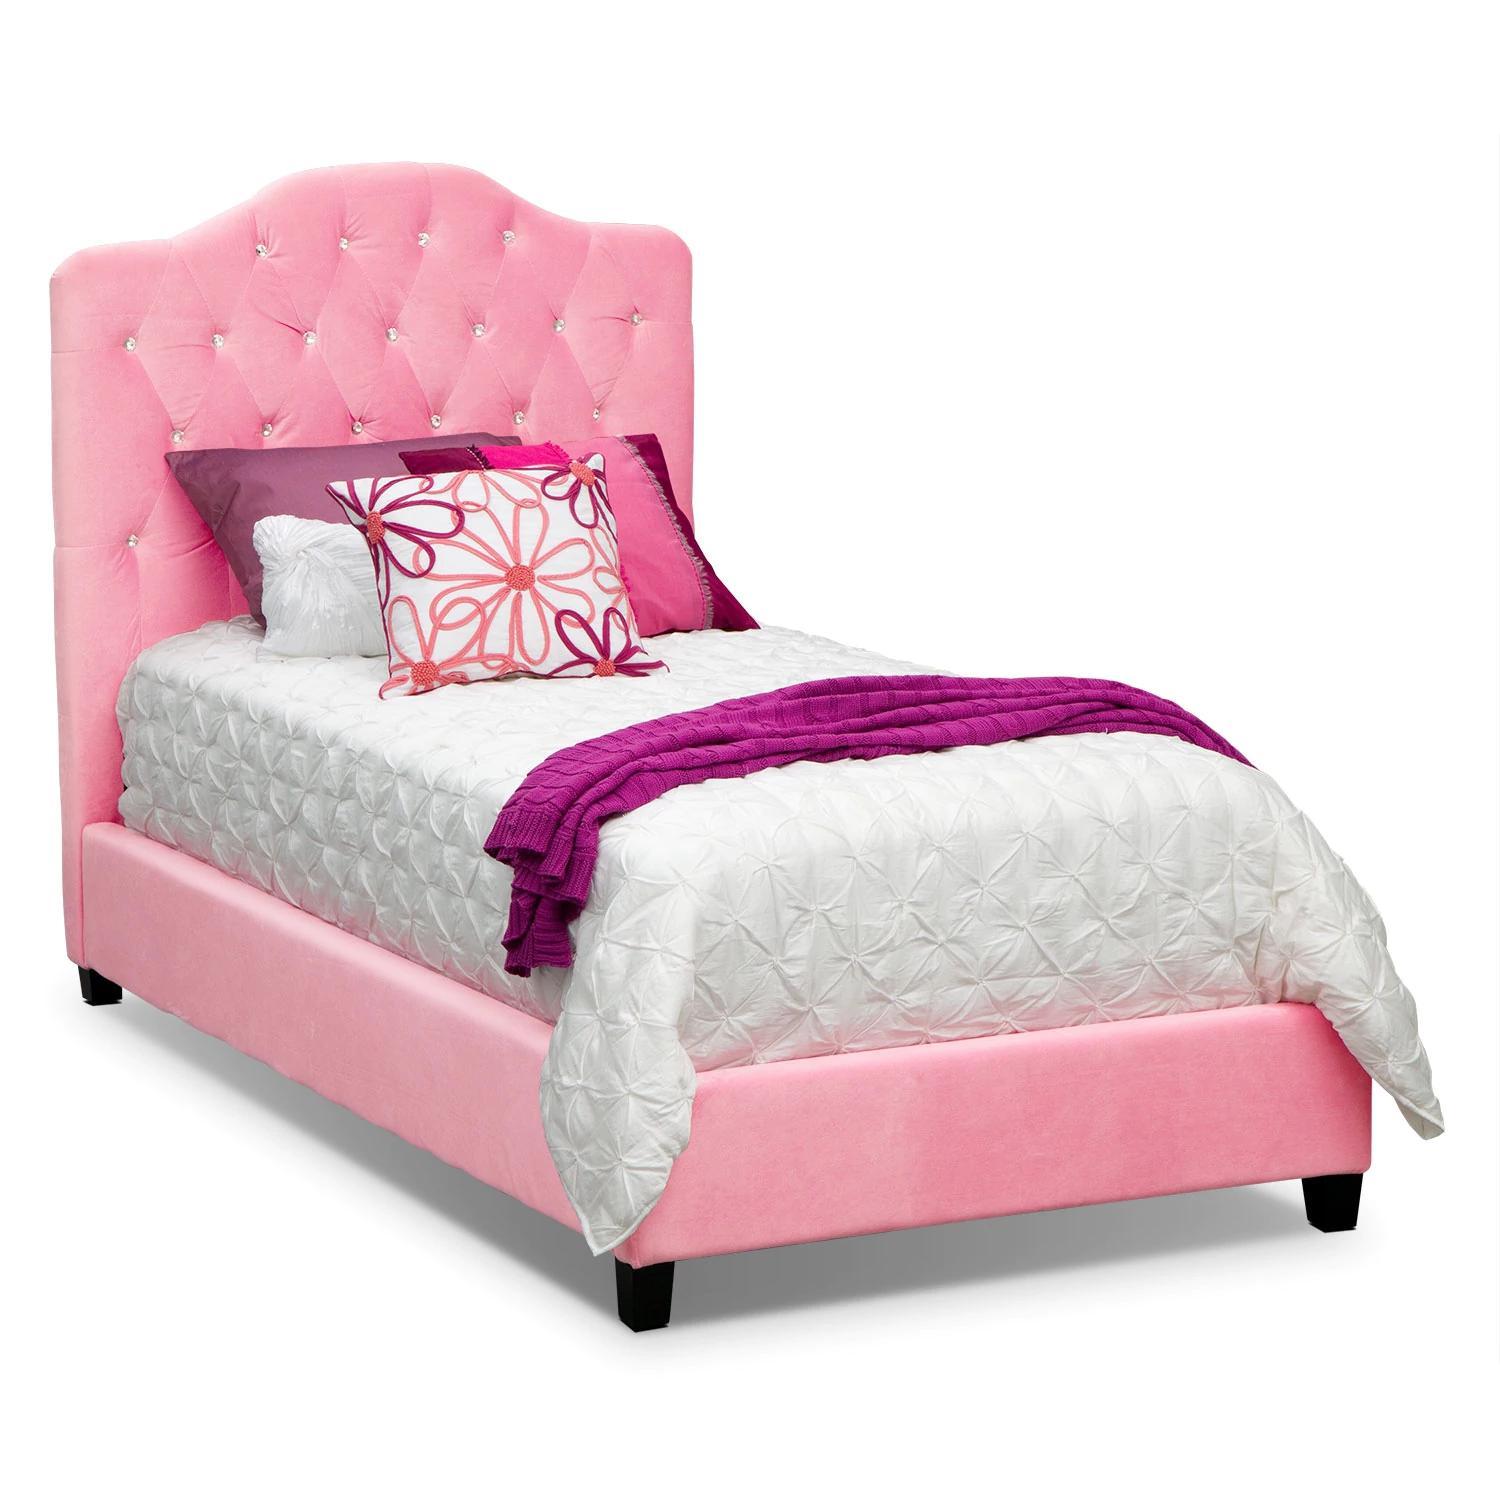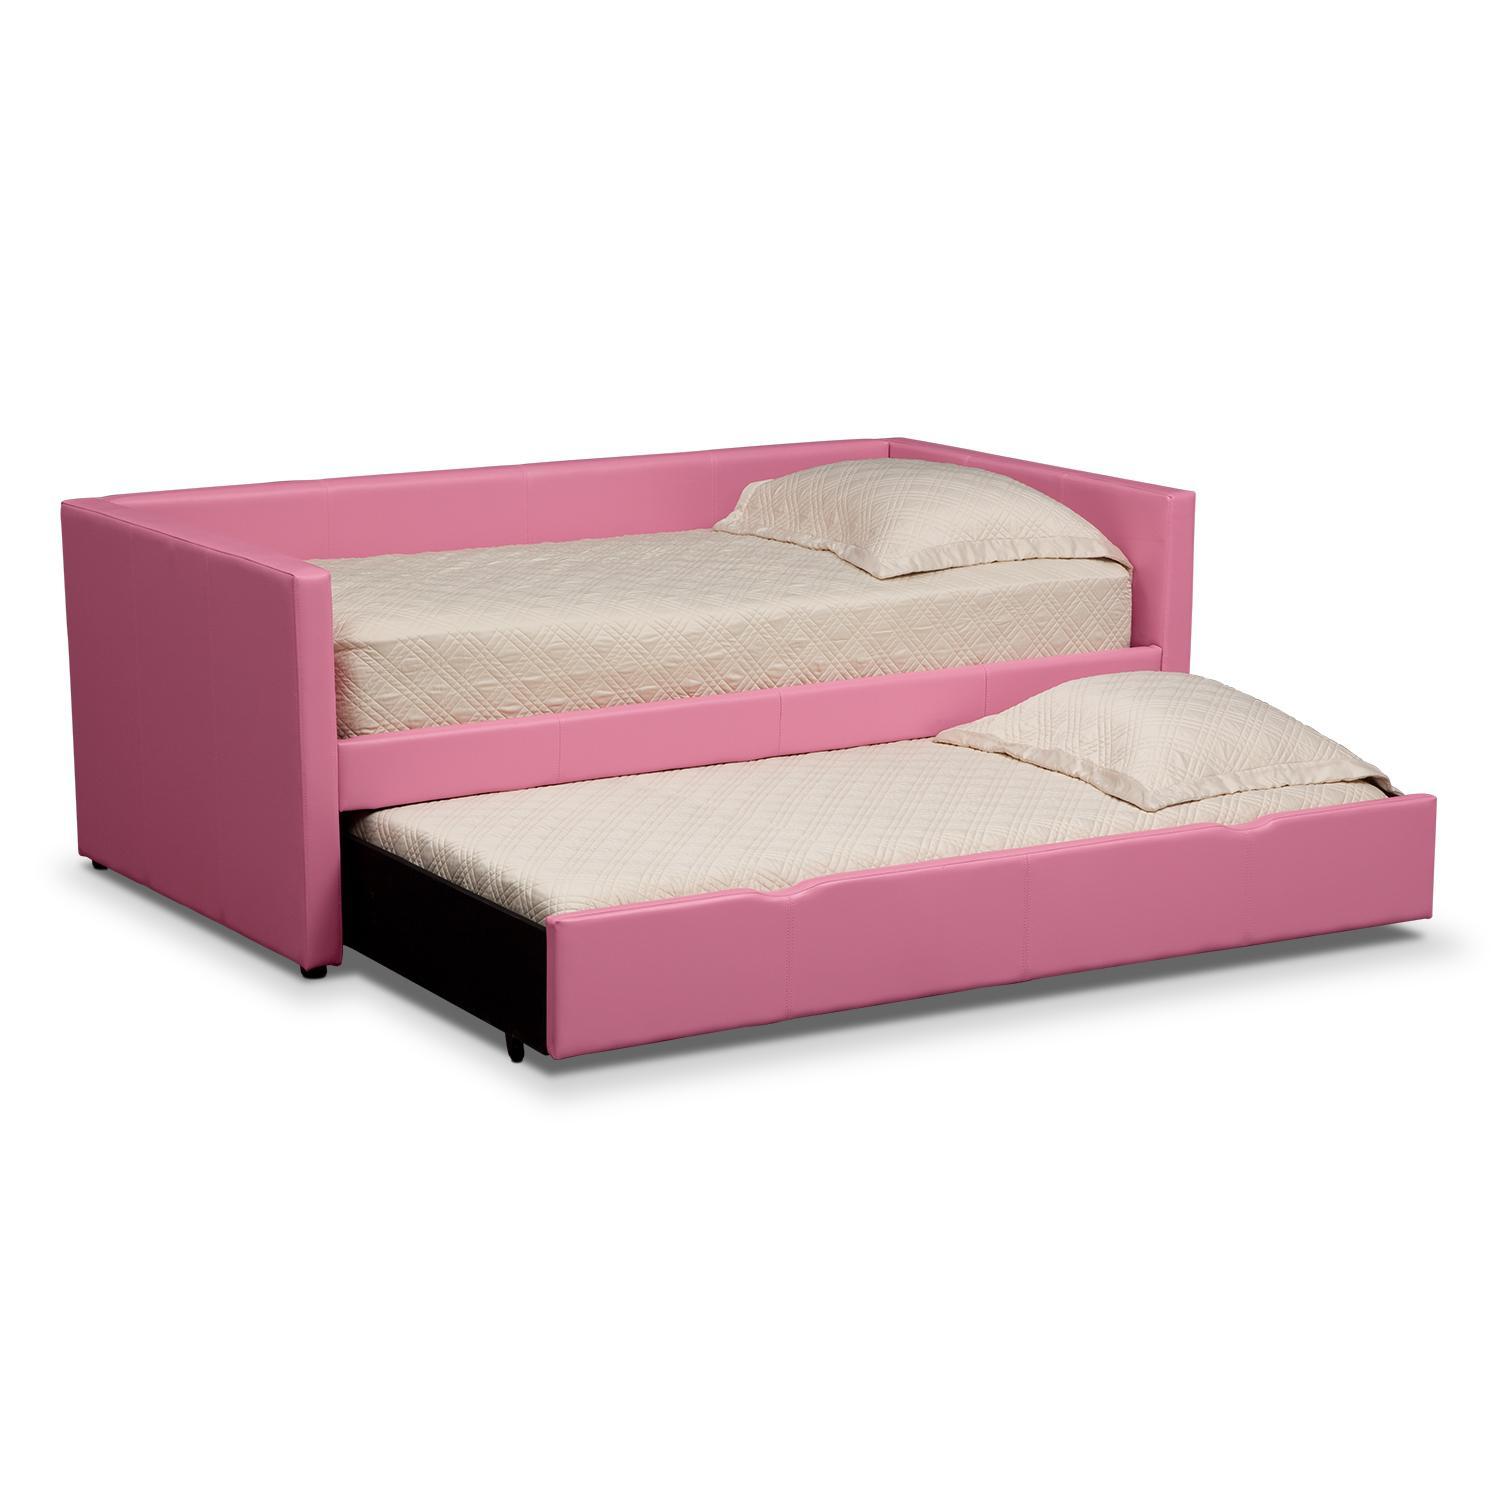The first image is the image on the left, the second image is the image on the right. Considering the images on both sides, is "There is a single pink bed with a pull out trundle bed attached underneath it" valid? Answer yes or no. Yes. 